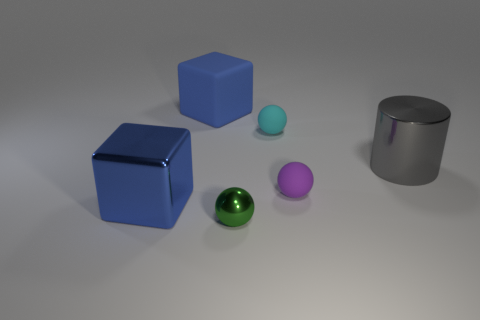Subtract all green cylinders. Subtract all yellow blocks. How many cylinders are left? 1 Add 2 brown rubber cylinders. How many objects exist? 8 Subtract all cubes. How many objects are left? 4 Add 4 small green balls. How many small green balls exist? 5 Subtract 0 cyan cubes. How many objects are left? 6 Subtract all small green metal spheres. Subtract all green shiny balls. How many objects are left? 4 Add 3 small green spheres. How many small green spheres are left? 4 